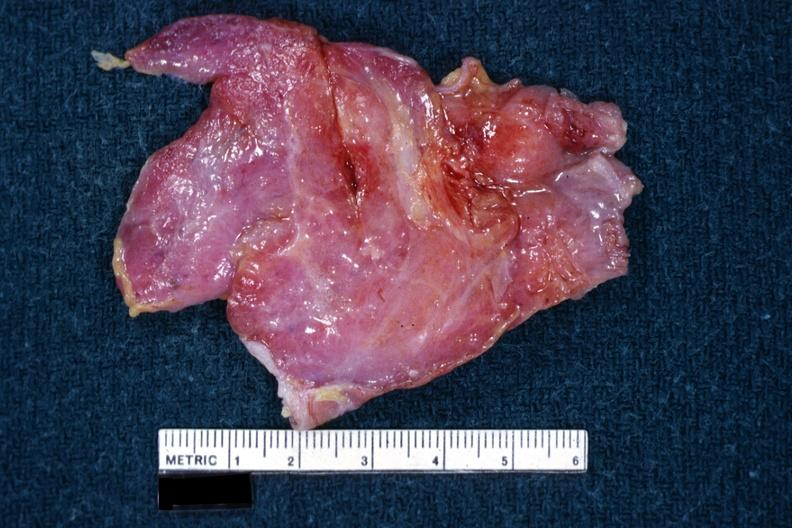does this image show i am not sure of diagnosis?
Answer the question using a single word or phrase. Yes 